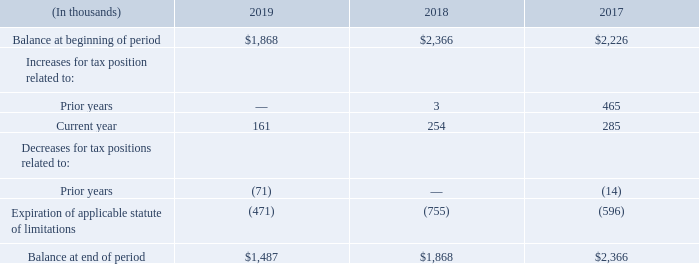During 2019, 2018 and 2017, no income tax benefit or expense was recorded for stock options exercised as an adjustment to equity.
The change in the unrecognized income tax benefits for the years ended December 31, 2019, 2018 and 2017 is reconciled below:
As of December 31, 2019, 2018 and 2017, our total liability for unrecognized tax benefits was $1.5 million, $1.9 million and $2.4 million, respectively, of which $1.4 million, $1.7 million and $2.2 million, respectively, would reduce our effective tax rate if we were successful in upholding all of the uncertain positions and recognized the amounts recorded. We classify interest and penalties recognized on the liability for unrecognized tax benefits as income tax expense. As of December 31, 2019, 2018 and 2017, the balances of accrued interest and penalties were $0.5 million, $0.7 million and $0.8 million, respectively.
We do not anticipate a single tax position generating a significant increase or decrease in our liability for unrecognized tax benefits within 12 months of this reporting date. We file income tax returns in the U.S. for federal and various state jurisdictions and several foreign jurisdictions. We are not currently under audit by the Internal Revenue Service. Generally, we are not subject to changes in income taxes by any taxing jurisdiction for the years prior to 2016.
What was the company's total liability for unrecognized tax benefits in 2019?
Answer scale should be: million. $1.5 million. What does the table show? Change in the unrecognized income tax benefits for the years ended december 31, 2019, 2018 and 2017. What is the  Balance at beginning of period for 2019?
Answer scale should be: thousand. $1,868. What was the change in the balance at the beginning of period between 2018 and 2019?
Answer scale should be: thousand. $1,868-$2,366
Answer: -498. What was the change in the balance at the end of period between 2018 and 2019?
Answer scale should be: thousand. $1,487-$1,868
Answer: -381. What was the percentage change in the expiration of applicable statute of limitations between 2017 and 2018?
Answer scale should be: percent. (-755-(-596))/-596
Answer: 26.68. 